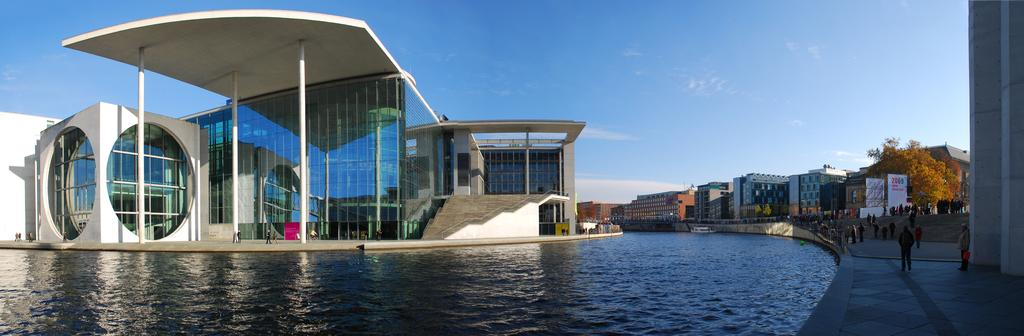What type of structures can be seen in the image? There are buildings in the image. What are the vertical structures in the image? There are poles in the image. What type of advertisements are present in the image? There are hoardings in the image. What type of vegetation is present in the image? There are trees in the image. What type of architectural elements can be seen in the image? There are pillars in the image. Who or what is present in the image? There are people in the image. What type of watercraft is visible in the image? There is a boat on the water in the image. What part of the natural environment is visible in the image? The sky is visible in the image. What type of weather can be inferred from the image? There are clouds in the sky, suggesting a partly cloudy day. What type of account is being discussed in the image? There is no account being discussed in the image; it features buildings, poles, hoardings, trees, pillars, people, a boat, and clouds. What type of basket is visible in the image? There is no basket present in the image. 